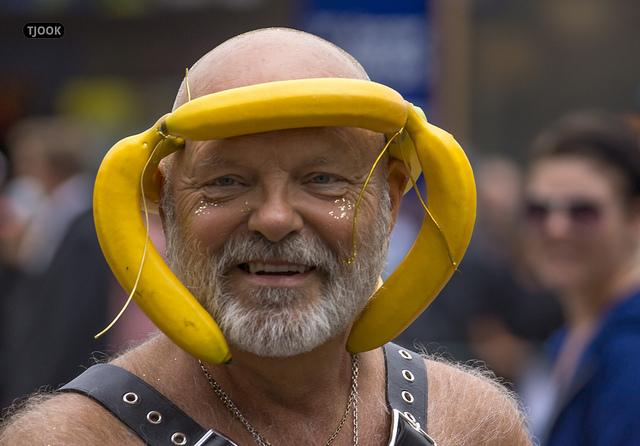If the man eats what is around his head what vitamin will he get? Please explain your reasoning. vitamin c. Bananas are known to contain vitamin c. 